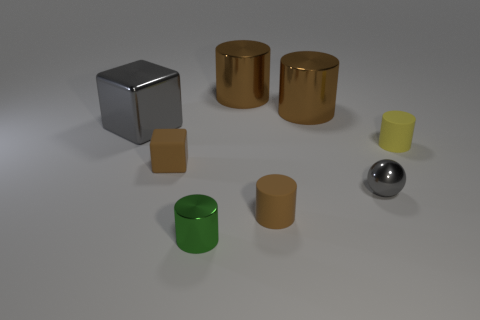Is the shape of the yellow thing the same as the green metal object?
Give a very brief answer. Yes. How many brown things are in front of the big metal cube and on the right side of the matte block?
Your answer should be very brief. 1. Are there an equal number of brown things that are to the left of the large gray metallic thing and gray balls behind the brown rubber block?
Give a very brief answer. Yes. Does the matte cylinder behind the tiny gray metallic thing have the same size as the gray thing that is on the left side of the metallic ball?
Keep it short and to the point. No. What is the material of the object that is in front of the gray cube and behind the small block?
Offer a terse response. Rubber. Is the number of metal objects less than the number of tiny yellow cylinders?
Give a very brief answer. No. What is the size of the gray metallic cube that is left of the small metal thing that is on the right side of the small green shiny object?
Make the answer very short. Large. The brown thing that is on the left side of the tiny green cylinder that is in front of the gray thing that is to the right of the big gray metallic thing is what shape?
Your response must be concise. Cube. What color is the small cylinder that is the same material as the tiny gray ball?
Your answer should be compact. Green. There is a cube that is in front of the small matte cylinder behind the brown cylinder that is in front of the big gray metal thing; what is its color?
Your answer should be compact. Brown. 